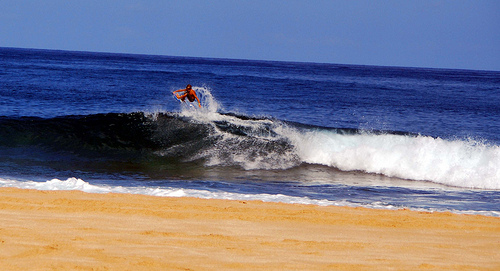Can you tell if the surfer is experienced or a beginner, and what clues lead you to this assessment? Judging from the poise and positioning of the surfer atop the steep face of the wave and their efficient control over the board, we can infer a level of experience and skill. Such finesse often comes from dedicated practice and intimate knowledge of wave patterns. 